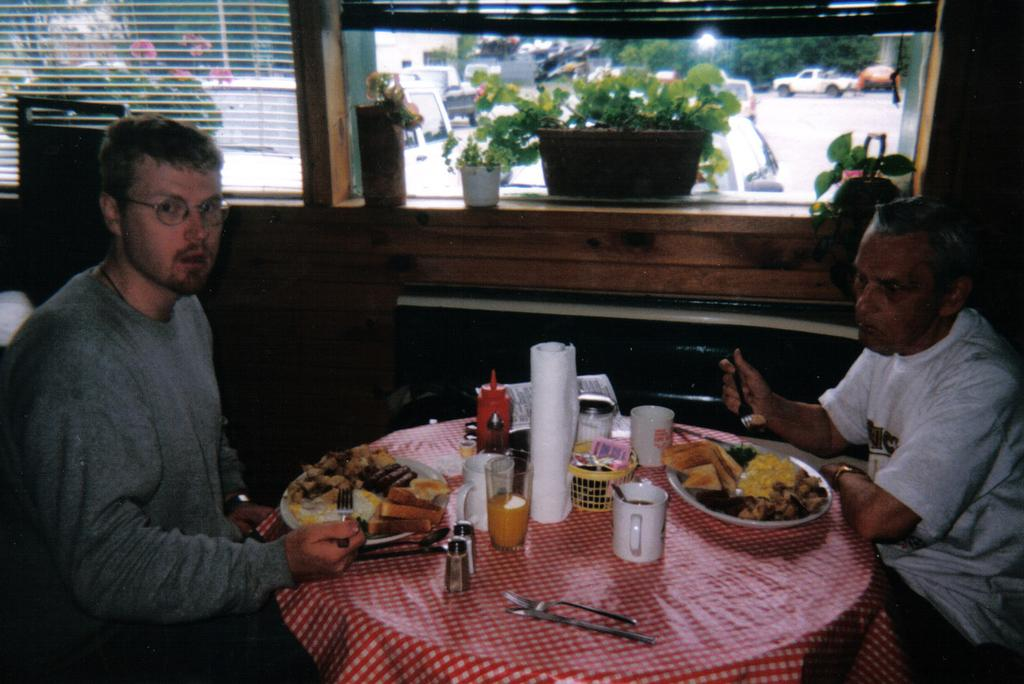How many people are in the image? There are two persons in the image. What are the persons doing in the image? The persons are sitting on chairs. What is in front of the persons? There is a table in front of the persons. What is on the table? The table has eatables on it. What is beside the persons? There are small plants beside the persons. What type of carriage can be seen in the image? There is no carriage present in the image. What suggestion is being made by the persons in the image? The image does not provide any information about a suggestion being made by the persons. 